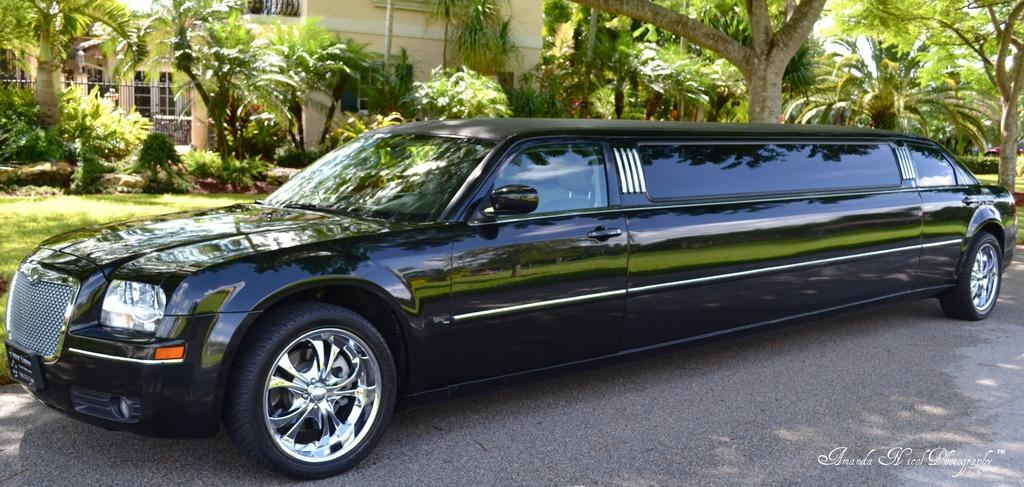What is the main subject in the center of the image? There is a car in the center of the image. Where is the car located? The car is on the road. What can be seen in the background of the image? There are trees, plants, grass, and a building in the background of the image. What type of suit can be seen hanging from the tree in the image? There is no suit hanging from a tree in the image; it only features a car on the road and various elements in the background. 